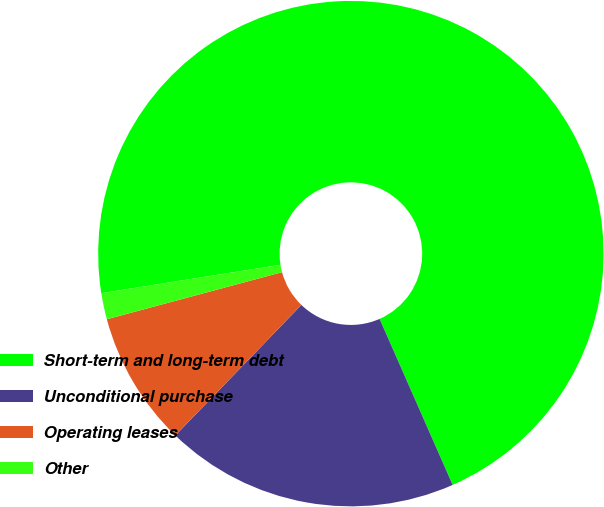<chart> <loc_0><loc_0><loc_500><loc_500><pie_chart><fcel>Short-term and long-term debt<fcel>Unconditional purchase<fcel>Operating leases<fcel>Other<nl><fcel>70.91%<fcel>18.82%<fcel>8.6%<fcel>1.68%<nl></chart> 